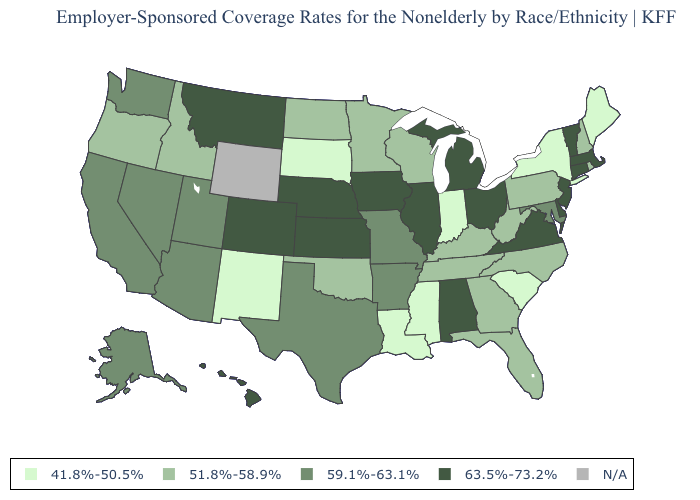What is the value of Mississippi?
Write a very short answer. 41.8%-50.5%. How many symbols are there in the legend?
Keep it brief. 5. What is the value of Hawaii?
Short answer required. 63.5%-73.2%. Does New Hampshire have the lowest value in the Northeast?
Be succinct. No. What is the lowest value in the South?
Short answer required. 41.8%-50.5%. Name the states that have a value in the range 41.8%-50.5%?
Keep it brief. Indiana, Louisiana, Maine, Mississippi, New Mexico, New York, South Carolina, South Dakota. What is the lowest value in the South?
Be succinct. 41.8%-50.5%. Does Arkansas have the lowest value in the USA?
Write a very short answer. No. What is the value of Georgia?
Be succinct. 51.8%-58.9%. What is the lowest value in the West?
Short answer required. 41.8%-50.5%. What is the value of Minnesota?
Keep it brief. 51.8%-58.9%. Which states have the lowest value in the MidWest?
Be succinct. Indiana, South Dakota. What is the lowest value in states that border New York?
Keep it brief. 51.8%-58.9%. Name the states that have a value in the range 59.1%-63.1%?
Concise answer only. Alaska, Arizona, Arkansas, California, Maryland, Missouri, Nevada, Texas, Utah, Washington. 